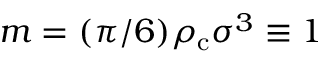<formula> <loc_0><loc_0><loc_500><loc_500>m = ( \pi / 6 ) \rho _ { c } \sigma ^ { 3 } \equiv 1</formula> 